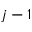Convert formula to latex. <formula><loc_0><loc_0><loc_500><loc_500>j - 1</formula> 